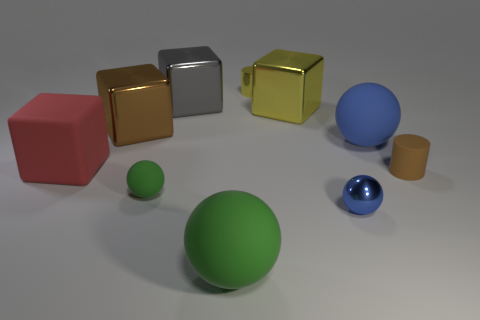Subtract 1 cubes. How many cubes are left? 3 Subtract all spheres. How many objects are left? 6 Subtract all gray cubes. Subtract all matte blocks. How many objects are left? 8 Add 2 large matte objects. How many large matte objects are left? 5 Add 4 big yellow spheres. How many big yellow spheres exist? 4 Subtract 0 cyan cylinders. How many objects are left? 10 